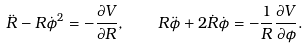Convert formula to latex. <formula><loc_0><loc_0><loc_500><loc_500>\ddot { R } - R \dot { \phi } ^ { 2 } = - \frac { \partial V } { \partial R } , \quad R \ddot { \phi } + 2 \dot { R } \dot { \phi } = - \frac { 1 } { R } \frac { \partial V } { \partial \phi } .</formula> 